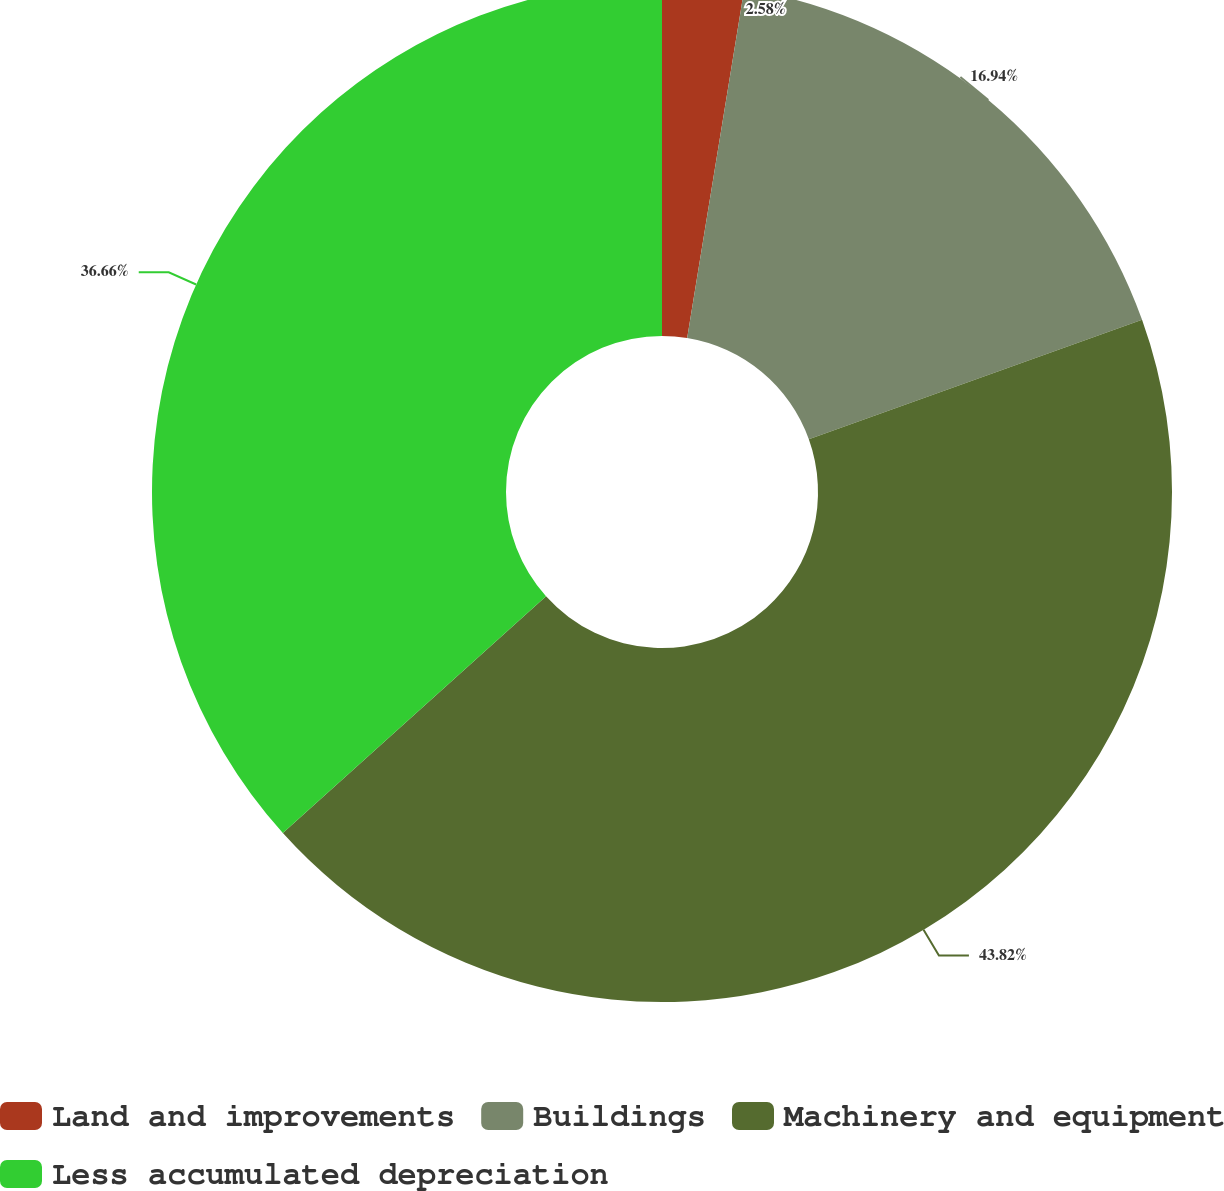Convert chart. <chart><loc_0><loc_0><loc_500><loc_500><pie_chart><fcel>Land and improvements<fcel>Buildings<fcel>Machinery and equipment<fcel>Less accumulated depreciation<nl><fcel>2.58%<fcel>16.94%<fcel>43.82%<fcel>36.66%<nl></chart> 